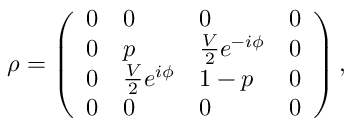Convert formula to latex. <formula><loc_0><loc_0><loc_500><loc_500>\rho = \left ( \begin{array} { l l l l } { 0 } & { 0 } & { 0 } & { 0 } \\ { 0 } & { p } & { { \frac { V } { 2 } e ^ { - i \phi } } } & { 0 } \\ { 0 } & { { \frac { V } { 2 } e ^ { i \phi } } } & { 1 - p } & { 0 } \\ { 0 } & { 0 } & { 0 } & { 0 } \end{array} \right ) ,</formula> 